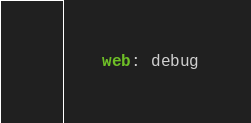Convert code to text. <code><loc_0><loc_0><loc_500><loc_500><_YAML_>    web: debug</code> 